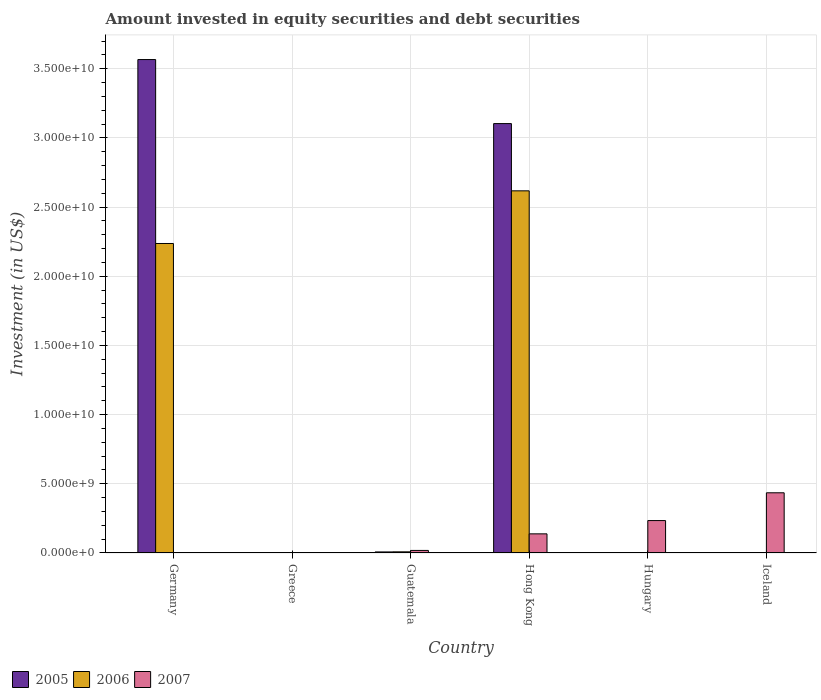How many different coloured bars are there?
Give a very brief answer. 3. Are the number of bars per tick equal to the number of legend labels?
Your response must be concise. No. How many bars are there on the 5th tick from the left?
Ensure brevity in your answer.  1. How many bars are there on the 2nd tick from the right?
Your answer should be very brief. 1. What is the label of the 2nd group of bars from the left?
Your answer should be very brief. Greece. In how many cases, is the number of bars for a given country not equal to the number of legend labels?
Offer a very short reply. 4. What is the amount invested in equity securities and debt securities in 2007 in Greece?
Keep it short and to the point. 0. Across all countries, what is the maximum amount invested in equity securities and debt securities in 2005?
Offer a very short reply. 3.57e+1. Across all countries, what is the minimum amount invested in equity securities and debt securities in 2006?
Keep it short and to the point. 0. In which country was the amount invested in equity securities and debt securities in 2007 maximum?
Offer a very short reply. Iceland. What is the total amount invested in equity securities and debt securities in 2005 in the graph?
Provide a short and direct response. 6.68e+1. What is the difference between the amount invested in equity securities and debt securities in 2005 in Germany and that in Guatemala?
Keep it short and to the point. 3.56e+1. What is the difference between the amount invested in equity securities and debt securities in 2007 in Iceland and the amount invested in equity securities and debt securities in 2005 in Greece?
Provide a short and direct response. 4.35e+09. What is the average amount invested in equity securities and debt securities in 2006 per country?
Your answer should be compact. 8.11e+09. What is the difference between the amount invested in equity securities and debt securities of/in 2007 and amount invested in equity securities and debt securities of/in 2006 in Guatemala?
Make the answer very short. 1.02e+08. In how many countries, is the amount invested in equity securities and debt securities in 2005 greater than 11000000000 US$?
Provide a succinct answer. 2. What is the ratio of the amount invested in equity securities and debt securities in 2007 in Hungary to that in Iceland?
Your answer should be compact. 0.54. Is the amount invested in equity securities and debt securities in 2006 in Germany less than that in Hong Kong?
Your response must be concise. Yes. What is the difference between the highest and the second highest amount invested in equity securities and debt securities in 2005?
Offer a very short reply. 3.56e+1. What is the difference between the highest and the lowest amount invested in equity securities and debt securities in 2005?
Your response must be concise. 3.57e+1. Is it the case that in every country, the sum of the amount invested in equity securities and debt securities in 2006 and amount invested in equity securities and debt securities in 2007 is greater than the amount invested in equity securities and debt securities in 2005?
Provide a succinct answer. No. Are all the bars in the graph horizontal?
Your response must be concise. No. How many countries are there in the graph?
Ensure brevity in your answer.  6. What is the difference between two consecutive major ticks on the Y-axis?
Give a very brief answer. 5.00e+09. Does the graph contain any zero values?
Your response must be concise. Yes. Where does the legend appear in the graph?
Offer a terse response. Bottom left. How many legend labels are there?
Keep it short and to the point. 3. What is the title of the graph?
Your response must be concise. Amount invested in equity securities and debt securities. Does "2007" appear as one of the legend labels in the graph?
Your answer should be very brief. Yes. What is the label or title of the Y-axis?
Give a very brief answer. Investment (in US$). What is the Investment (in US$) in 2005 in Germany?
Keep it short and to the point. 3.57e+1. What is the Investment (in US$) in 2006 in Germany?
Provide a succinct answer. 2.24e+1. What is the Investment (in US$) in 2007 in Germany?
Provide a short and direct response. 0. What is the Investment (in US$) in 2005 in Guatemala?
Give a very brief answer. 7.68e+07. What is the Investment (in US$) in 2006 in Guatemala?
Offer a very short reply. 8.34e+07. What is the Investment (in US$) of 2007 in Guatemala?
Offer a terse response. 1.85e+08. What is the Investment (in US$) of 2005 in Hong Kong?
Your answer should be compact. 3.10e+1. What is the Investment (in US$) of 2006 in Hong Kong?
Keep it short and to the point. 2.62e+1. What is the Investment (in US$) of 2007 in Hong Kong?
Keep it short and to the point. 1.38e+09. What is the Investment (in US$) of 2007 in Hungary?
Offer a very short reply. 2.34e+09. What is the Investment (in US$) of 2005 in Iceland?
Give a very brief answer. 0. What is the Investment (in US$) of 2006 in Iceland?
Give a very brief answer. 0. What is the Investment (in US$) in 2007 in Iceland?
Offer a very short reply. 4.35e+09. Across all countries, what is the maximum Investment (in US$) in 2005?
Provide a short and direct response. 3.57e+1. Across all countries, what is the maximum Investment (in US$) in 2006?
Make the answer very short. 2.62e+1. Across all countries, what is the maximum Investment (in US$) in 2007?
Your answer should be compact. 4.35e+09. Across all countries, what is the minimum Investment (in US$) of 2005?
Give a very brief answer. 0. What is the total Investment (in US$) of 2005 in the graph?
Ensure brevity in your answer.  6.68e+1. What is the total Investment (in US$) in 2006 in the graph?
Make the answer very short. 4.86e+1. What is the total Investment (in US$) of 2007 in the graph?
Give a very brief answer. 8.26e+09. What is the difference between the Investment (in US$) in 2005 in Germany and that in Guatemala?
Ensure brevity in your answer.  3.56e+1. What is the difference between the Investment (in US$) in 2006 in Germany and that in Guatemala?
Provide a short and direct response. 2.23e+1. What is the difference between the Investment (in US$) of 2005 in Germany and that in Hong Kong?
Make the answer very short. 4.63e+09. What is the difference between the Investment (in US$) of 2006 in Germany and that in Hong Kong?
Your answer should be very brief. -3.81e+09. What is the difference between the Investment (in US$) of 2005 in Guatemala and that in Hong Kong?
Make the answer very short. -3.10e+1. What is the difference between the Investment (in US$) in 2006 in Guatemala and that in Hong Kong?
Your response must be concise. -2.61e+1. What is the difference between the Investment (in US$) in 2007 in Guatemala and that in Hong Kong?
Offer a terse response. -1.20e+09. What is the difference between the Investment (in US$) of 2007 in Guatemala and that in Hungary?
Your answer should be compact. -2.16e+09. What is the difference between the Investment (in US$) in 2007 in Guatemala and that in Iceland?
Provide a short and direct response. -4.17e+09. What is the difference between the Investment (in US$) of 2007 in Hong Kong and that in Hungary?
Give a very brief answer. -9.60e+08. What is the difference between the Investment (in US$) of 2007 in Hong Kong and that in Iceland?
Your answer should be compact. -2.97e+09. What is the difference between the Investment (in US$) of 2007 in Hungary and that in Iceland?
Provide a short and direct response. -2.01e+09. What is the difference between the Investment (in US$) of 2005 in Germany and the Investment (in US$) of 2006 in Guatemala?
Your answer should be compact. 3.56e+1. What is the difference between the Investment (in US$) of 2005 in Germany and the Investment (in US$) of 2007 in Guatemala?
Offer a terse response. 3.55e+1. What is the difference between the Investment (in US$) of 2006 in Germany and the Investment (in US$) of 2007 in Guatemala?
Your answer should be compact. 2.22e+1. What is the difference between the Investment (in US$) in 2005 in Germany and the Investment (in US$) in 2006 in Hong Kong?
Offer a very short reply. 9.49e+09. What is the difference between the Investment (in US$) of 2005 in Germany and the Investment (in US$) of 2007 in Hong Kong?
Provide a succinct answer. 3.43e+1. What is the difference between the Investment (in US$) of 2006 in Germany and the Investment (in US$) of 2007 in Hong Kong?
Provide a short and direct response. 2.10e+1. What is the difference between the Investment (in US$) of 2005 in Germany and the Investment (in US$) of 2007 in Hungary?
Your response must be concise. 3.33e+1. What is the difference between the Investment (in US$) in 2006 in Germany and the Investment (in US$) in 2007 in Hungary?
Give a very brief answer. 2.00e+1. What is the difference between the Investment (in US$) in 2005 in Germany and the Investment (in US$) in 2007 in Iceland?
Your response must be concise. 3.13e+1. What is the difference between the Investment (in US$) in 2006 in Germany and the Investment (in US$) in 2007 in Iceland?
Offer a very short reply. 1.80e+1. What is the difference between the Investment (in US$) in 2005 in Guatemala and the Investment (in US$) in 2006 in Hong Kong?
Ensure brevity in your answer.  -2.61e+1. What is the difference between the Investment (in US$) in 2005 in Guatemala and the Investment (in US$) in 2007 in Hong Kong?
Ensure brevity in your answer.  -1.31e+09. What is the difference between the Investment (in US$) in 2006 in Guatemala and the Investment (in US$) in 2007 in Hong Kong?
Your answer should be very brief. -1.30e+09. What is the difference between the Investment (in US$) in 2005 in Guatemala and the Investment (in US$) in 2007 in Hungary?
Provide a succinct answer. -2.27e+09. What is the difference between the Investment (in US$) of 2006 in Guatemala and the Investment (in US$) of 2007 in Hungary?
Give a very brief answer. -2.26e+09. What is the difference between the Investment (in US$) in 2005 in Guatemala and the Investment (in US$) in 2007 in Iceland?
Provide a succinct answer. -4.27e+09. What is the difference between the Investment (in US$) in 2006 in Guatemala and the Investment (in US$) in 2007 in Iceland?
Make the answer very short. -4.27e+09. What is the difference between the Investment (in US$) in 2005 in Hong Kong and the Investment (in US$) in 2007 in Hungary?
Provide a short and direct response. 2.87e+1. What is the difference between the Investment (in US$) in 2006 in Hong Kong and the Investment (in US$) in 2007 in Hungary?
Offer a terse response. 2.38e+1. What is the difference between the Investment (in US$) in 2005 in Hong Kong and the Investment (in US$) in 2007 in Iceland?
Provide a short and direct response. 2.67e+1. What is the difference between the Investment (in US$) in 2006 in Hong Kong and the Investment (in US$) in 2007 in Iceland?
Ensure brevity in your answer.  2.18e+1. What is the average Investment (in US$) of 2005 per country?
Keep it short and to the point. 1.11e+1. What is the average Investment (in US$) in 2006 per country?
Your response must be concise. 8.11e+09. What is the average Investment (in US$) of 2007 per country?
Your answer should be compact. 1.38e+09. What is the difference between the Investment (in US$) of 2005 and Investment (in US$) of 2006 in Germany?
Keep it short and to the point. 1.33e+1. What is the difference between the Investment (in US$) of 2005 and Investment (in US$) of 2006 in Guatemala?
Make the answer very short. -6.60e+06. What is the difference between the Investment (in US$) in 2005 and Investment (in US$) in 2007 in Guatemala?
Ensure brevity in your answer.  -1.08e+08. What is the difference between the Investment (in US$) of 2006 and Investment (in US$) of 2007 in Guatemala?
Your answer should be compact. -1.02e+08. What is the difference between the Investment (in US$) in 2005 and Investment (in US$) in 2006 in Hong Kong?
Offer a very short reply. 4.86e+09. What is the difference between the Investment (in US$) in 2005 and Investment (in US$) in 2007 in Hong Kong?
Your response must be concise. 2.97e+1. What is the difference between the Investment (in US$) in 2006 and Investment (in US$) in 2007 in Hong Kong?
Give a very brief answer. 2.48e+1. What is the ratio of the Investment (in US$) of 2005 in Germany to that in Guatemala?
Your response must be concise. 464.44. What is the ratio of the Investment (in US$) of 2006 in Germany to that in Guatemala?
Give a very brief answer. 268.25. What is the ratio of the Investment (in US$) in 2005 in Germany to that in Hong Kong?
Keep it short and to the point. 1.15. What is the ratio of the Investment (in US$) in 2006 in Germany to that in Hong Kong?
Ensure brevity in your answer.  0.85. What is the ratio of the Investment (in US$) of 2005 in Guatemala to that in Hong Kong?
Offer a terse response. 0. What is the ratio of the Investment (in US$) of 2006 in Guatemala to that in Hong Kong?
Ensure brevity in your answer.  0. What is the ratio of the Investment (in US$) in 2007 in Guatemala to that in Hong Kong?
Make the answer very short. 0.13. What is the ratio of the Investment (in US$) in 2007 in Guatemala to that in Hungary?
Ensure brevity in your answer.  0.08. What is the ratio of the Investment (in US$) of 2007 in Guatemala to that in Iceland?
Offer a very short reply. 0.04. What is the ratio of the Investment (in US$) of 2007 in Hong Kong to that in Hungary?
Your answer should be compact. 0.59. What is the ratio of the Investment (in US$) in 2007 in Hong Kong to that in Iceland?
Offer a terse response. 0.32. What is the ratio of the Investment (in US$) of 2007 in Hungary to that in Iceland?
Ensure brevity in your answer.  0.54. What is the difference between the highest and the second highest Investment (in US$) of 2005?
Provide a succinct answer. 4.63e+09. What is the difference between the highest and the second highest Investment (in US$) in 2006?
Keep it short and to the point. 3.81e+09. What is the difference between the highest and the second highest Investment (in US$) of 2007?
Offer a very short reply. 2.01e+09. What is the difference between the highest and the lowest Investment (in US$) of 2005?
Keep it short and to the point. 3.57e+1. What is the difference between the highest and the lowest Investment (in US$) in 2006?
Make the answer very short. 2.62e+1. What is the difference between the highest and the lowest Investment (in US$) of 2007?
Make the answer very short. 4.35e+09. 